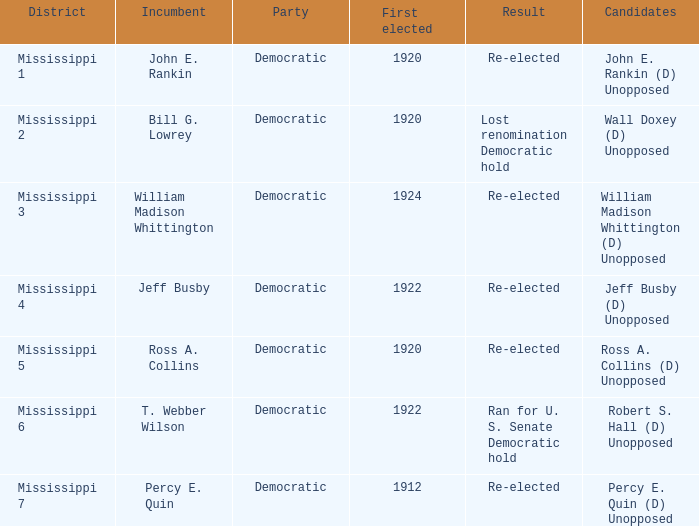What transpired in the election involving william madison whittington? Re-elected. 